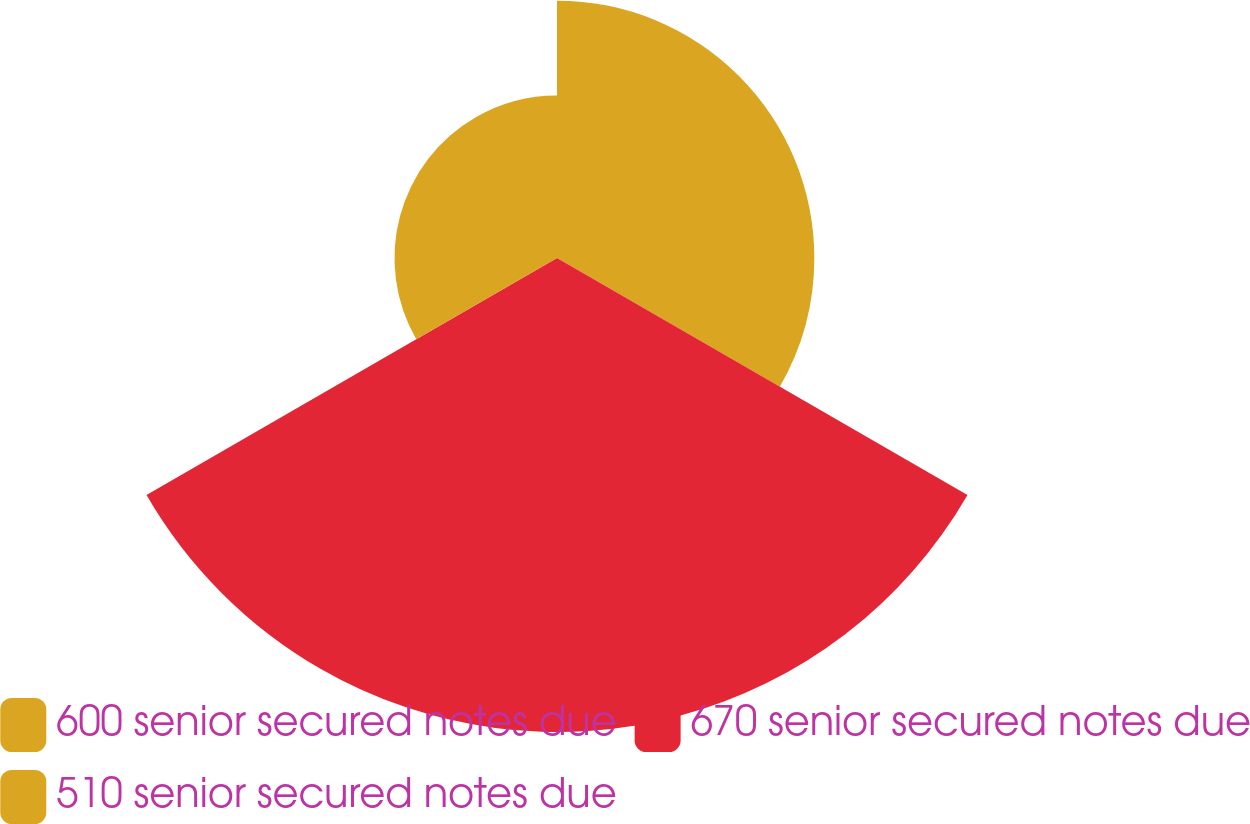Convert chart to OTSL. <chart><loc_0><loc_0><loc_500><loc_500><pie_chart><fcel>600 senior secured notes due<fcel>670 senior secured notes due<fcel>510 senior secured notes due<nl><fcel>28.79%<fcel>53.03%<fcel>18.18%<nl></chart> 